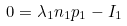Convert formula to latex. <formula><loc_0><loc_0><loc_500><loc_500>0 = \lambda _ { 1 } n _ { 1 } p _ { 1 } - I _ { 1 }</formula> 